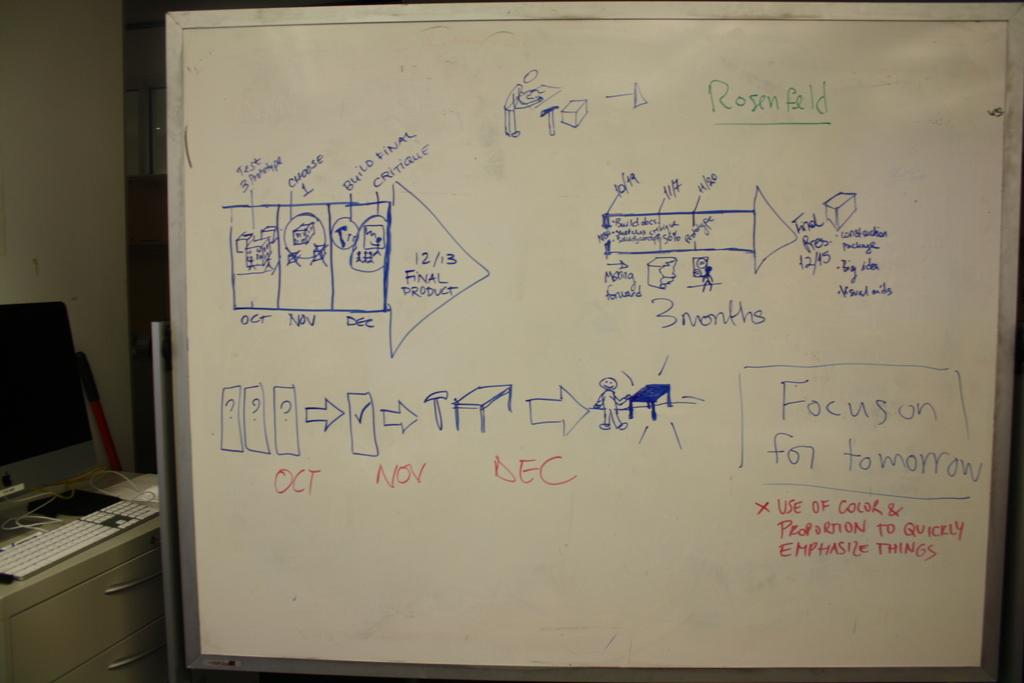Provide a one-sentence caption for the provided image. A white board with different diagrams on it explaining Focus on Tomorrow. 